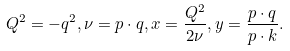Convert formula to latex. <formula><loc_0><loc_0><loc_500><loc_500>Q ^ { 2 } = - q ^ { 2 } , \nu = p \cdot q , x = \frac { Q ^ { 2 } } { 2 \nu } , y = \frac { p \cdot q } { p \cdot k } .</formula> 